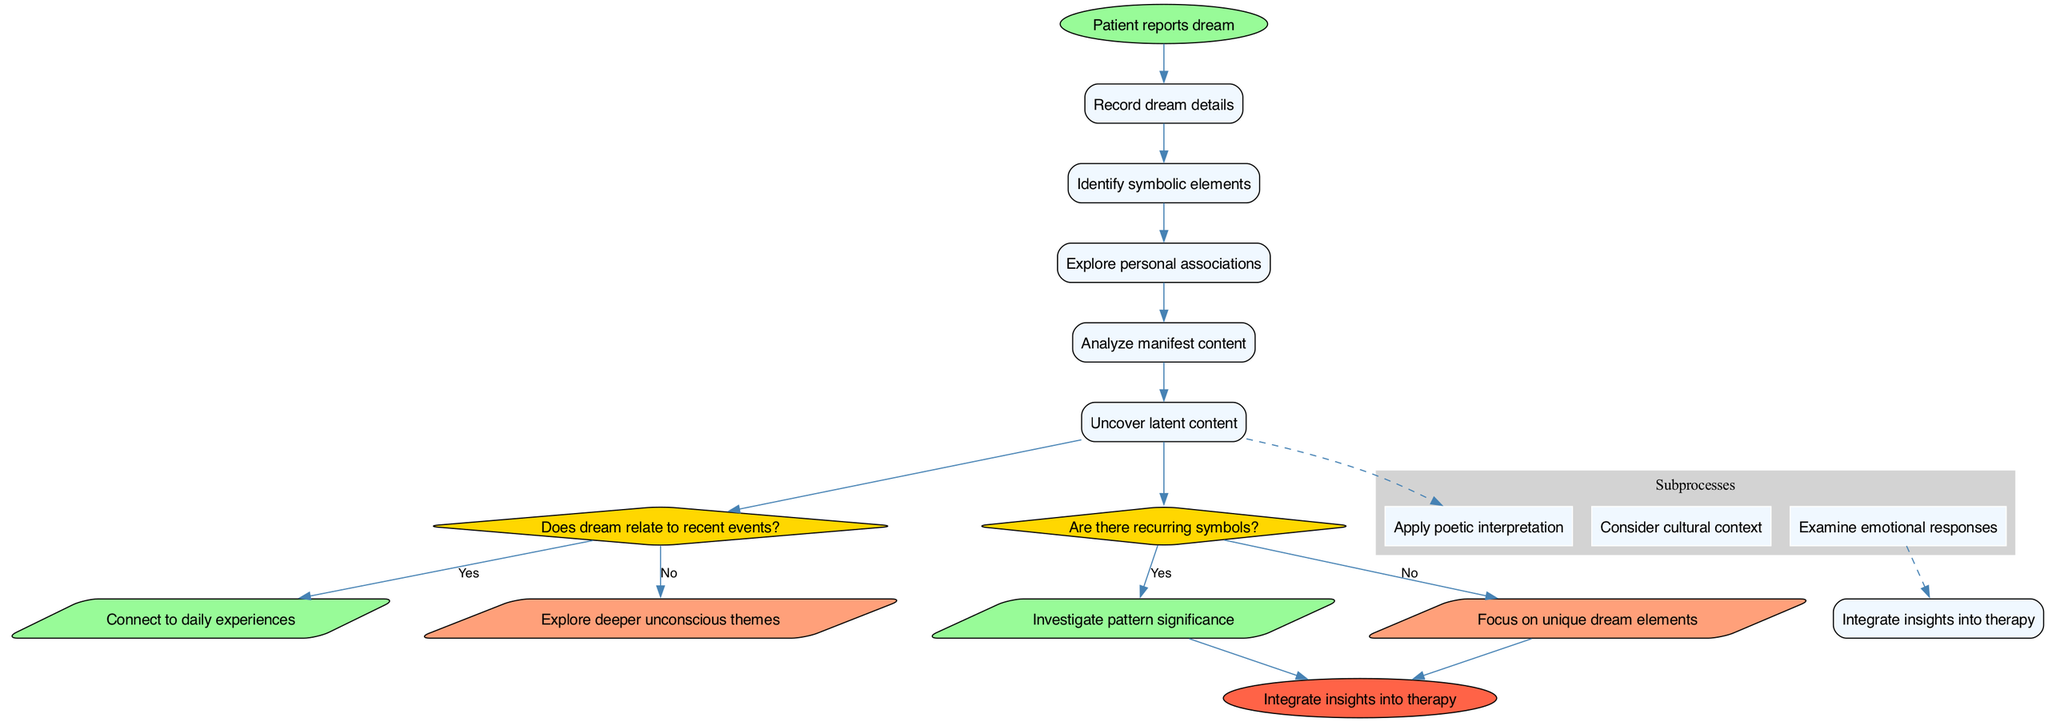What is the starting point of the process? The starting point is indicated by the "start" node, which shows that the process begins with the patient reporting a dream.
Answer: Patient reports dream How many processes are there in total? By counting the number of processes listed in the diagram, there are five distinct processes involved in interpreting dreams.
Answer: 5 What happens if the dream relates to recent events? In the diagram, if the dream relates to recent events, the flow leads to connecting the dream to daily experiences, as indicated by the 'Yes' path of the first decision.
Answer: Connect to daily experiences What is the last node in the process? The last node is where all interpretations converge, labeled as "Integrate insights into therapy," which signifies the culmination of the process of dream interpretation.
Answer: Integrate insights into therapy Which subprocess is connected via a dashed line? The dashed line connects "Examine emotional responses" to the primary flow, indicating that this subprocess is an additional consideration in the interpretation process of the dreams.
Answer: Examine emotional responses What is analyzed before uncovering latent content? Prior to reaching the latent content, "Analyze manifest content" is performed in the flow of interpreting the dream. This shows the sequential nature of the analysis.
Answer: Analyze manifest content If a recurring symbol is found in the dream, what is investigated? According to the "Yes" path from the relevant decision node, recurring symbols prompt an investigation into the significance of these patterns within the dream.
Answer: Investigate pattern significance What is the color of the decision nodes? The color of the decision nodes is specified as yellow, which visually distinguishes them from process nodes in the diagram.
Answer: Yellow 